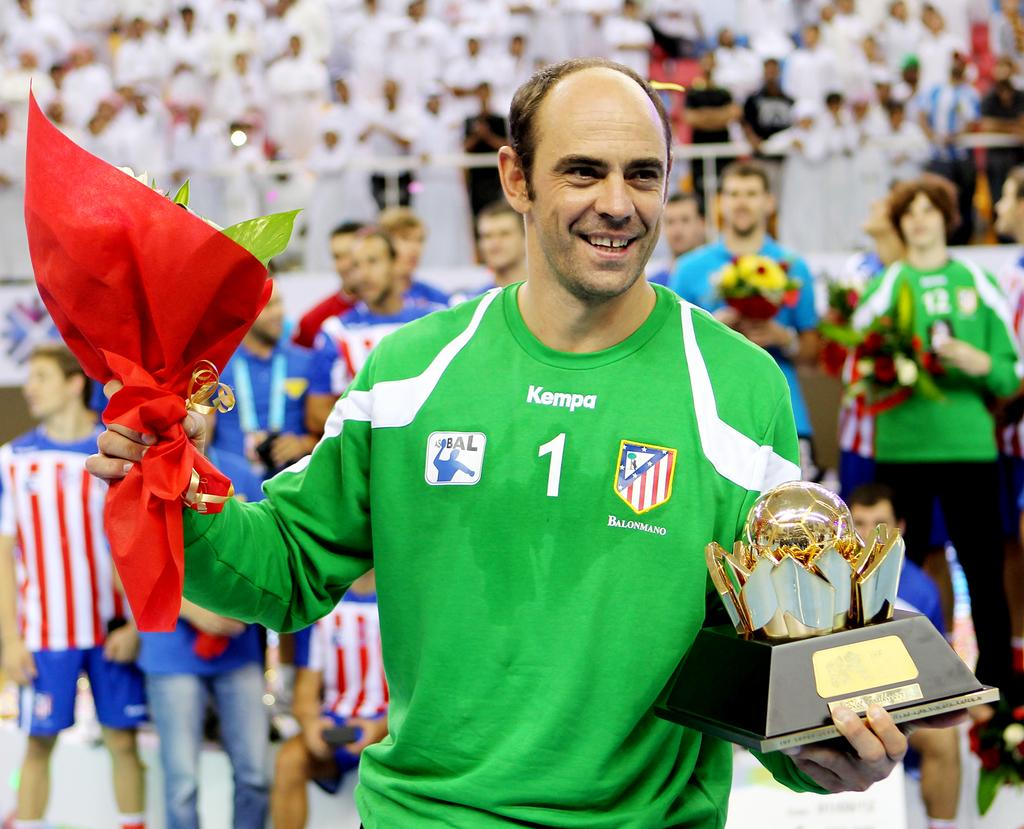Who is the main subject in the image? There is a man in the image. Where is the man located in relation to the image? The man is standing in the foreground. What is the man doing in the image? The man is holding two objects in his hands. Are there any other people visible in the image? Yes, there are other players visible in the image. Is the man wearing a veil in the image? A: There is no mention of a veil in the image, and the man is not wearing one. 